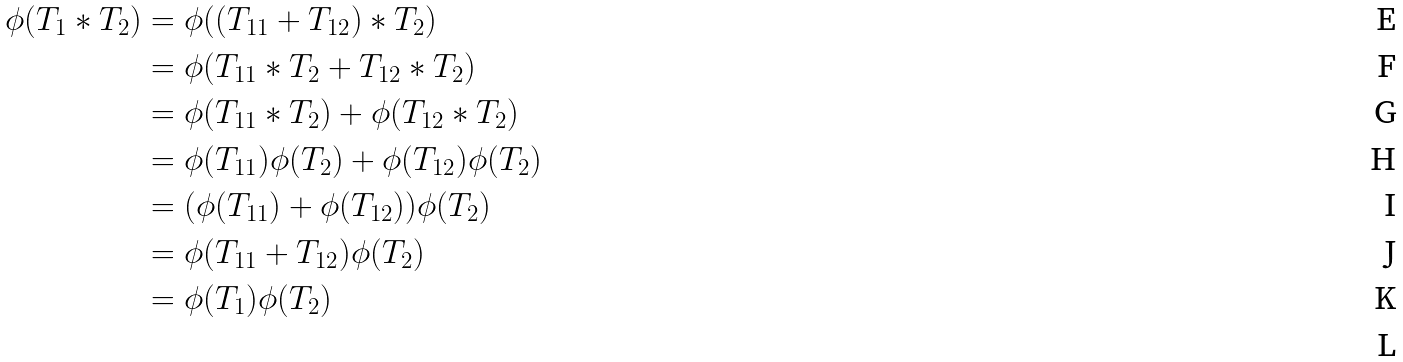Convert formula to latex. <formula><loc_0><loc_0><loc_500><loc_500>\phi ( T _ { 1 } * T _ { 2 } ) & = \phi ( ( T _ { 1 1 } + T _ { 1 2 } ) * T _ { 2 } ) \\ & = \phi ( T _ { 1 1 } * T _ { 2 } + T _ { 1 2 } * T _ { 2 } ) \\ & = \phi ( T _ { 1 1 } * T _ { 2 } ) + \phi ( T _ { 1 2 } * T _ { 2 } ) \\ & = \phi ( T _ { 1 1 } ) \phi ( T _ { 2 } ) + \phi ( T _ { 1 2 } ) \phi ( T _ { 2 } ) \\ & = ( \phi ( T _ { 1 1 } ) + \phi ( T _ { 1 2 } ) ) \phi ( T _ { 2 } ) \\ & = \phi ( T _ { 1 1 } + T _ { 1 2 } ) \phi ( T _ { 2 } ) \\ & = \phi ( T _ { 1 } ) \phi ( T _ { 2 } ) \\</formula> 